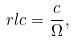Convert formula to latex. <formula><loc_0><loc_0><loc_500><loc_500>\ r l c = \frac { c } { \Omega } ,</formula> 